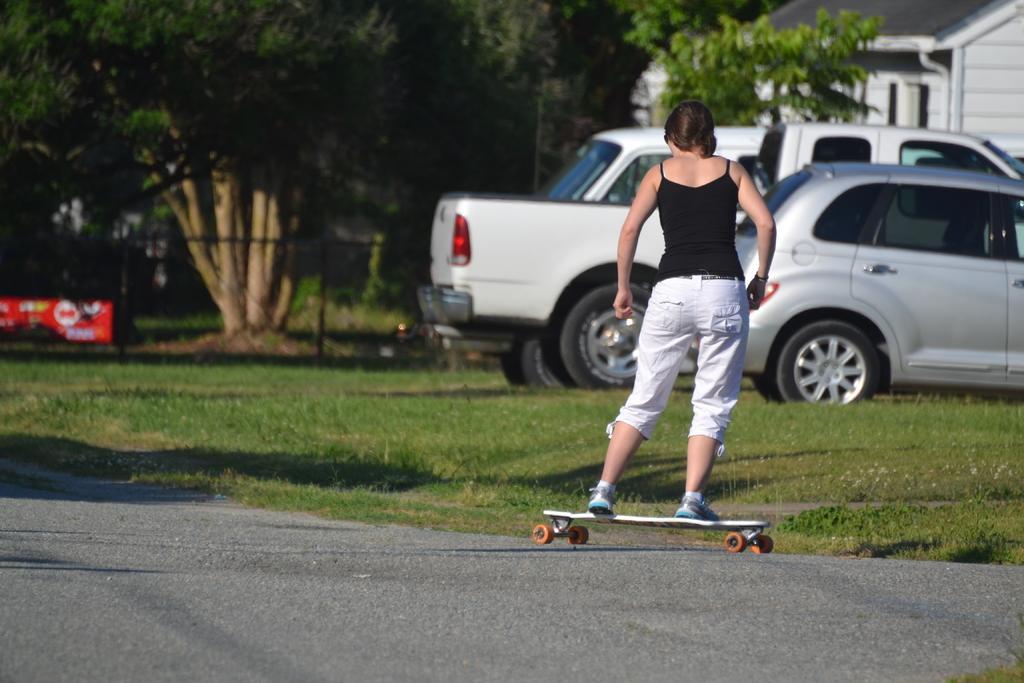Can you describe this image briefly? In this image we can see there is a girl standing on the skateboard on road, behind her there are cars parked in front of the building and there are some trees. 